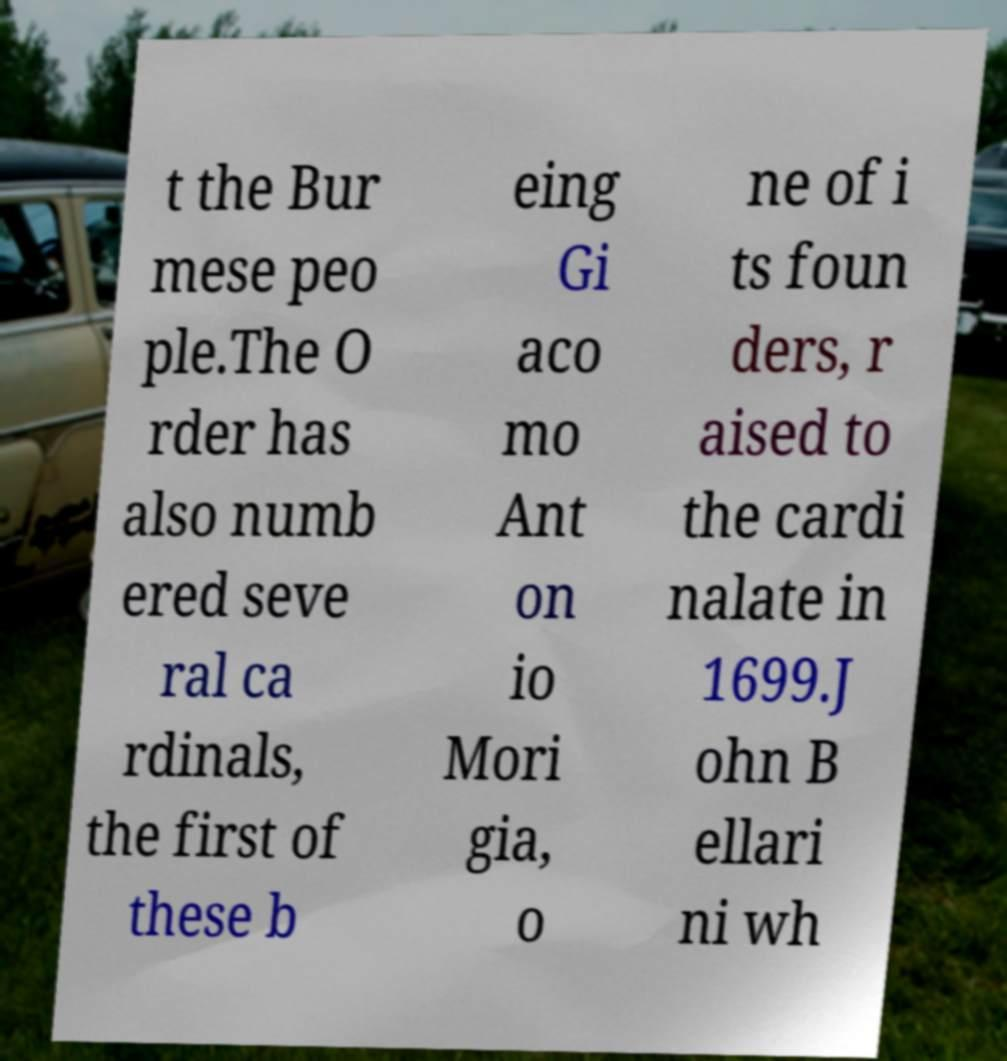Could you extract and type out the text from this image? t the Bur mese peo ple.The O rder has also numb ered seve ral ca rdinals, the first of these b eing Gi aco mo Ant on io Mori gia, o ne of i ts foun ders, r aised to the cardi nalate in 1699.J ohn B ellari ni wh 